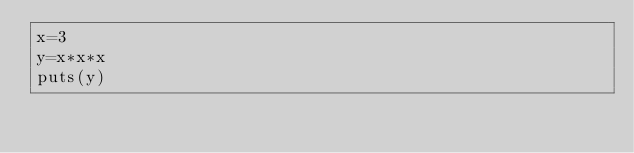<code> <loc_0><loc_0><loc_500><loc_500><_Ruby_>x=3
y=x*x*x
puts(y)</code> 